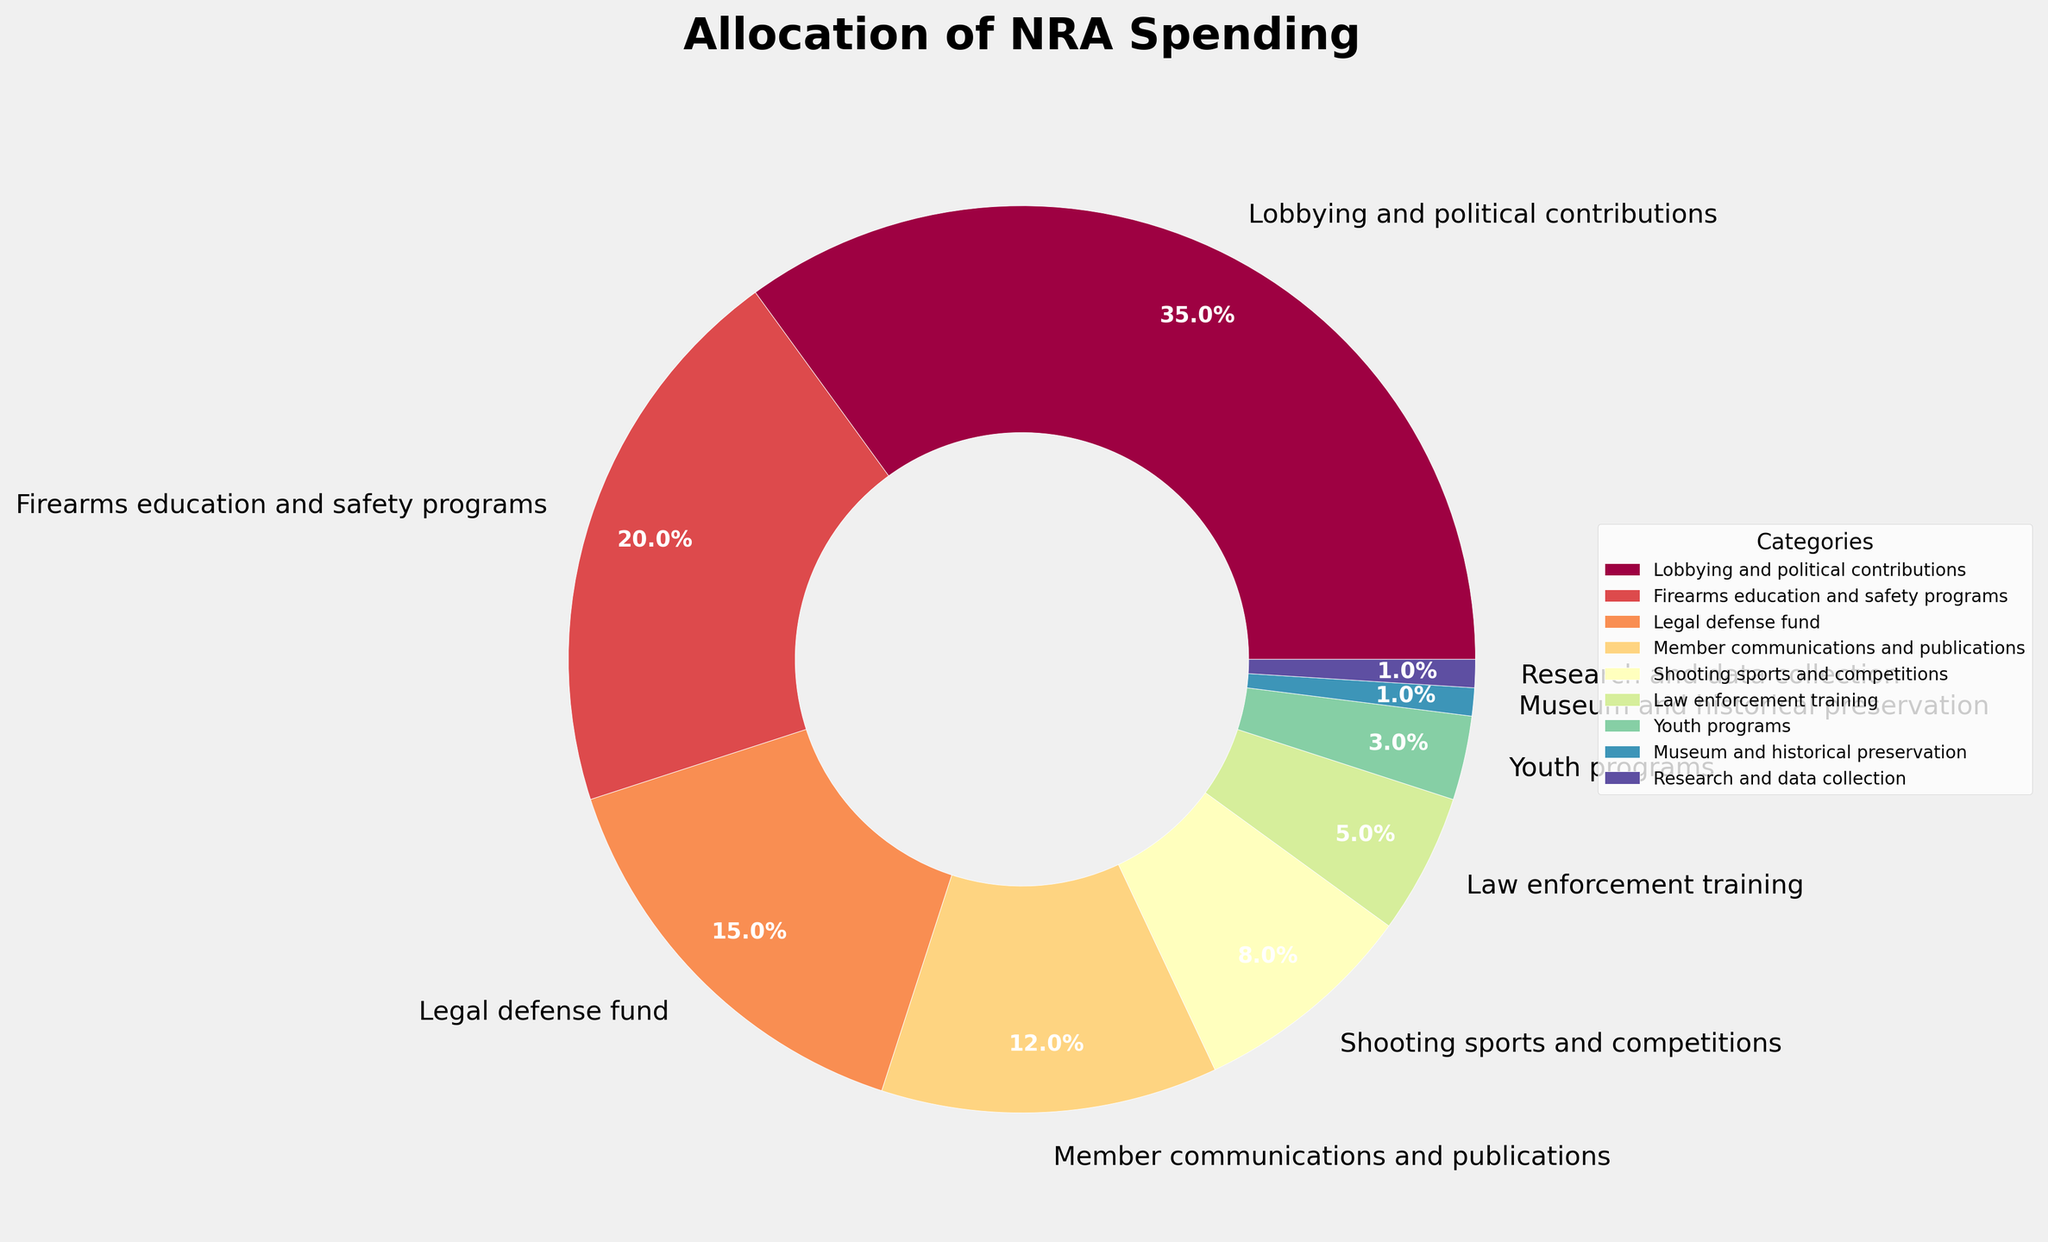What percentage of the NRA's spending is allocated to legal defense and youth programs combined? To find the combined spending on legal defense (15%) and youth programs (3%), we sum the percentages: 15% + 3% = 18%.
Answer: 18% Which category has the smallest percentage allocation, and what is that percentage? By examining the chart, we see that both "Museum and historical preservation" and "Research and data collection" have the smallest allocation at 1% each.
Answer: Museum and historical preservation, Research and data collection, 1% How much greater is the spending on lobbying and political contributions compared to firearms education and safety programs? The spending on lobbying and political contributions is 35%, while for firearms education and safety programs it is 20%. The difference is 35% - 20% = 15%.
Answer: 15% Which category has the third highest allocation in the NRA's spending? Reviewing the allocations, the first highest is "Lobbying and political contributions" (35%), the second is "Firearms education and safety programs" (20%), and the third is "Legal defense fund" (15%).
Answer: Legal defense fund What is the combined percentage of spending allocated to member communications and publications, shooting sports and competitions, and law enforcement training? Adding the percentages for these categories: 12% (member communications) + 8% (shooting sports) + 5% (law enforcement) = 25%.
Answer: 25% Is the percentage of spending on firearms education and safety programs greater than the sum of spending on law enforcement training, youth programs, and museum and historical preservation combined? Sum of law enforcement training (5%), youth programs (3%), and museum and historical preservation (1%) is 5% + 3% + 1% = 9%. The percentage for firearms education and safety programs is 20%, which is greater than 9%.
Answer: Yes How does the spending on shooting sports and competitions compare to law enforcement training? According to the chart, spending on shooting sports and competitions is 8%, whereas law enforcement training is 5%. Thus, spending on shooting sports and competitions is greater.
Answer: Shooting sports and competitions What is the difference between the percentage spending on legal defense fund and member communications and publications? The spending on legal defense fund is 15% and on member communications and publications is 12%. The difference is 15% - 12% = 3%.
Answer: 3% Which categories have less than 5% allocation in spending? Referring to the chart, the categories "Law enforcement training" (5%), "Youth programs" (3%), "Museum and historical preservation" (1%), and "Research and data collection" (1%) each have less than 5% allocation.
Answer: Youth programs, Museum and historical preservation, Research and data collection What's the percentage allocation if you add up the spending on member communications and publications, law enforcement training, and legal defense fund? The percentages are 12% (member communications), 5% (law enforcement training), and 15% (legal defense fund), adding up to 12% + 5% + 15% = 32%.
Answer: 32% 